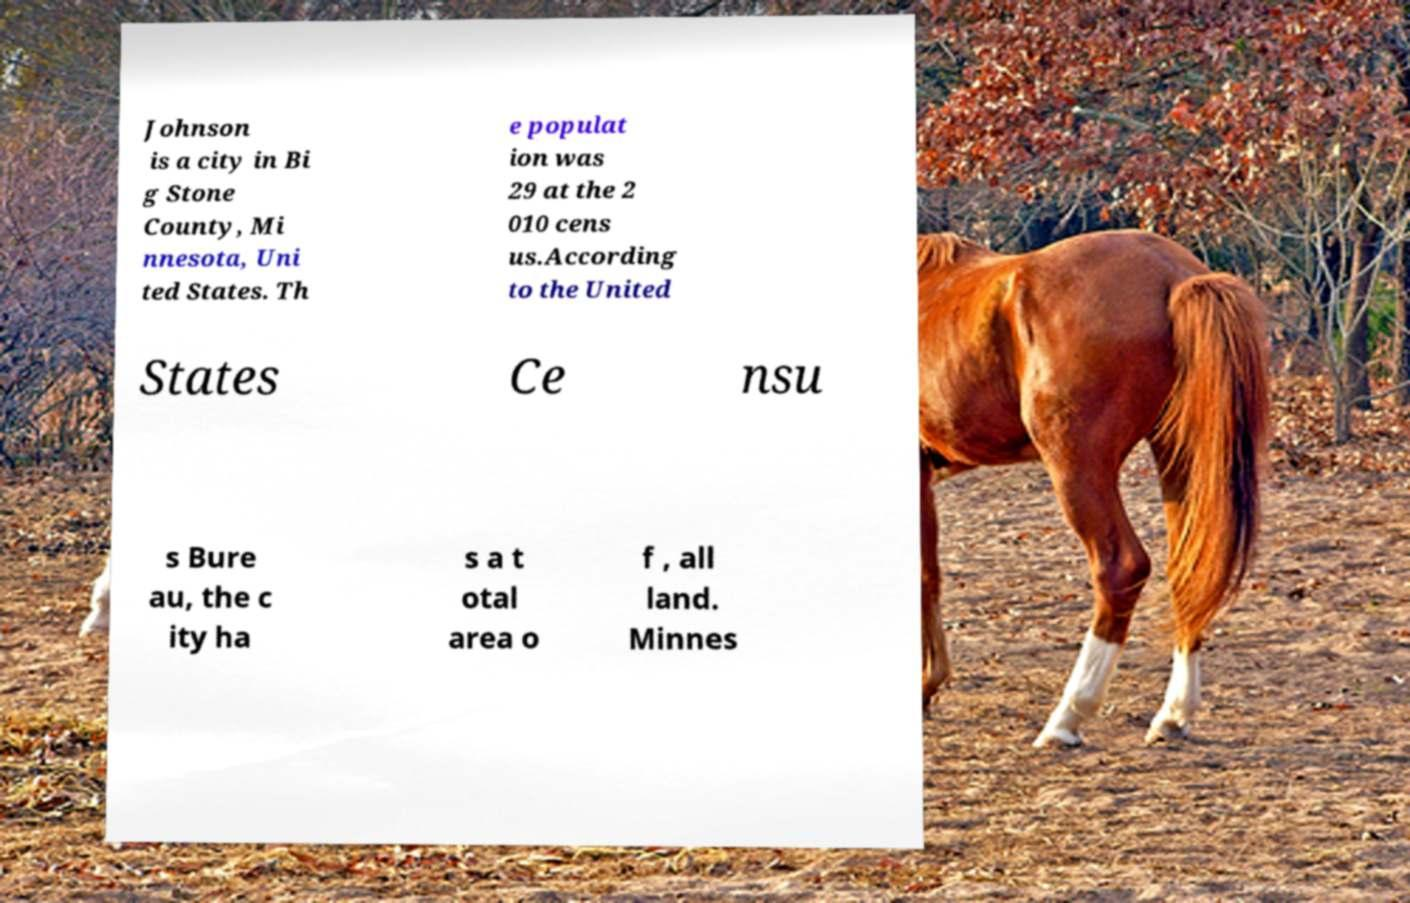Could you assist in decoding the text presented in this image and type it out clearly? Johnson is a city in Bi g Stone County, Mi nnesota, Uni ted States. Th e populat ion was 29 at the 2 010 cens us.According to the United States Ce nsu s Bure au, the c ity ha s a t otal area o f , all land. Minnes 